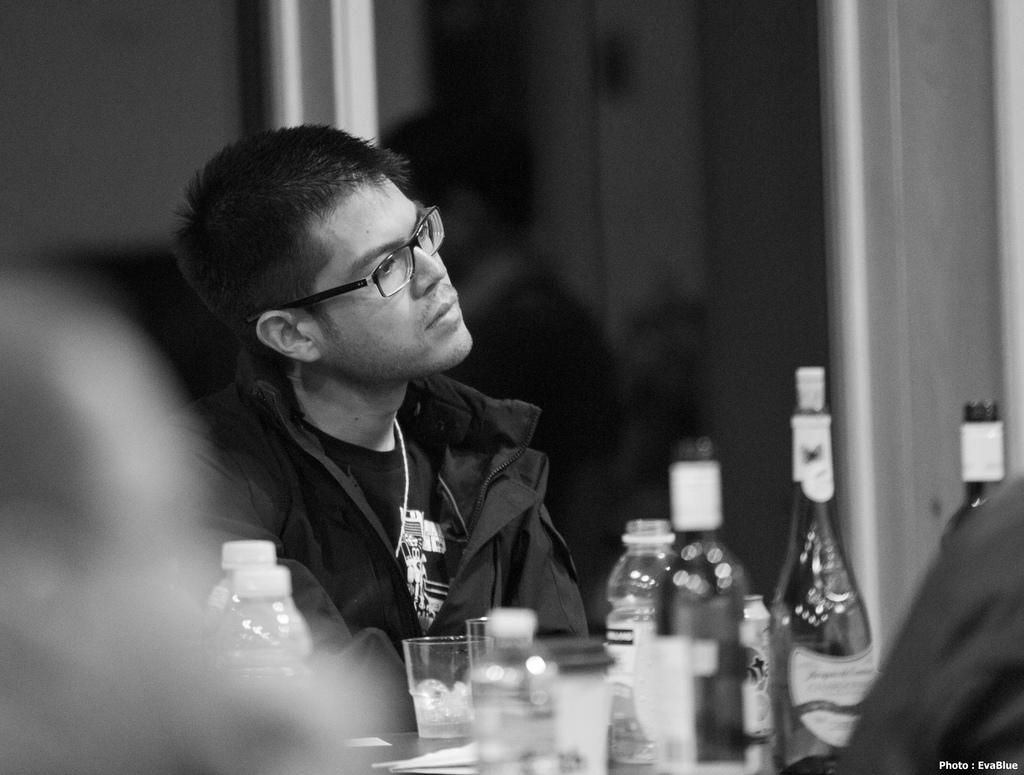Who is in the image? There is a person in the image. What is the person wearing? The person is wearing a black dress. What is the person doing in the image? The person is sitting. What objects are in front of the person? There are bottles and glasses in front of the person. What type of feast is being prepared in the image? There is no feast being prepared in the image; it only shows a person sitting with bottles and glasses in front of them. 